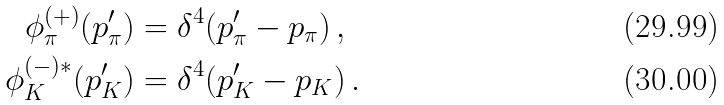<formula> <loc_0><loc_0><loc_500><loc_500>\phi _ { \pi } ^ { ( + ) } ( p _ { \pi } ^ { \prime } ) & = \delta ^ { 4 } ( p ^ { \prime } _ { \pi } - p _ { \pi } ) \, , \\ \phi _ { K } ^ { ( - ) * } ( p _ { K } ^ { \prime } ) & = \delta ^ { 4 } ( p ^ { \prime } _ { K } - p _ { K } ) \, .</formula> 